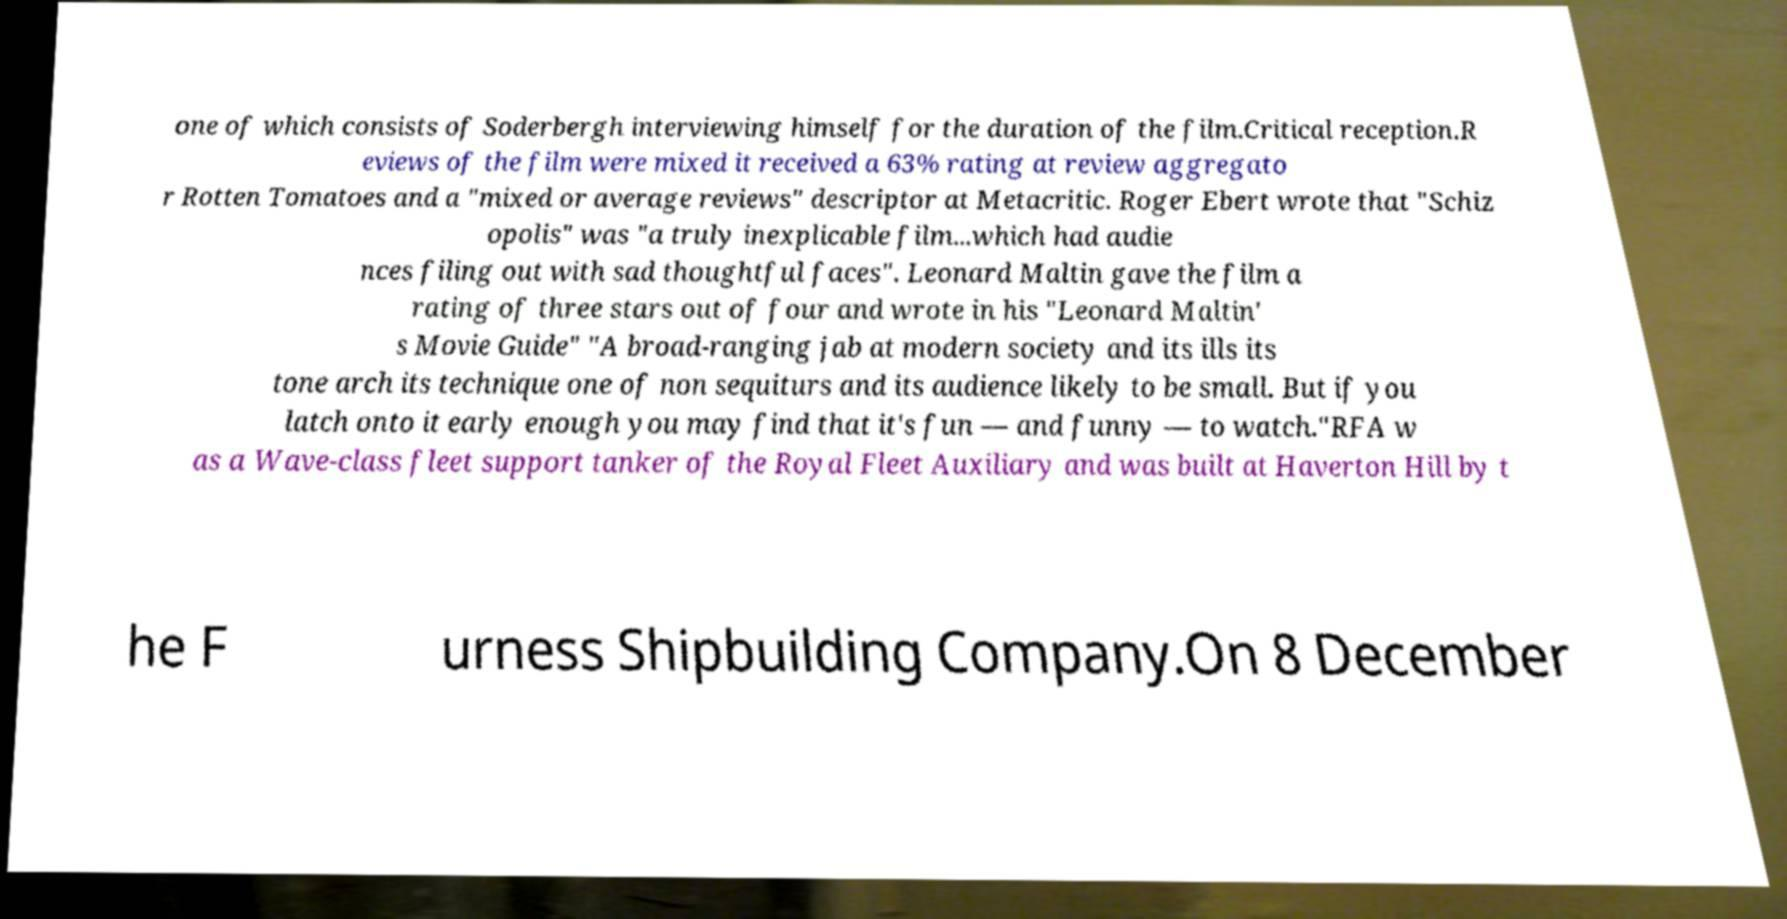There's text embedded in this image that I need extracted. Can you transcribe it verbatim? one of which consists of Soderbergh interviewing himself for the duration of the film.Critical reception.R eviews of the film were mixed it received a 63% rating at review aggregato r Rotten Tomatoes and a "mixed or average reviews" descriptor at Metacritic. Roger Ebert wrote that "Schiz opolis" was "a truly inexplicable film...which had audie nces filing out with sad thoughtful faces". Leonard Maltin gave the film a rating of three stars out of four and wrote in his "Leonard Maltin' s Movie Guide" "A broad-ranging jab at modern society and its ills its tone arch its technique one of non sequiturs and its audience likely to be small. But if you latch onto it early enough you may find that it's fun — and funny — to watch."RFA w as a Wave-class fleet support tanker of the Royal Fleet Auxiliary and was built at Haverton Hill by t he F urness Shipbuilding Company.On 8 December 